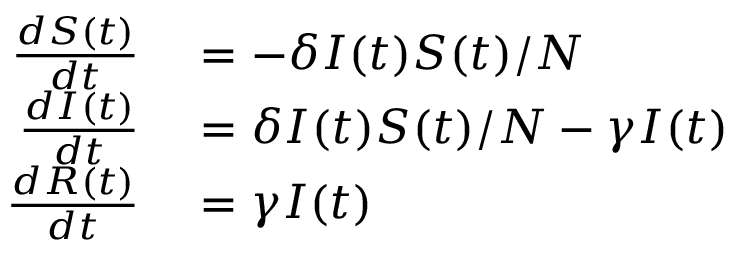Convert formula to latex. <formula><loc_0><loc_0><loc_500><loc_500>\begin{array} { r l } { \frac { d S ( t ) } { d t } } & = - \delta I ( t ) S ( t ) / N } \\ { \frac { d I ( t ) } { d t } } & = \delta I ( t ) S ( t ) / N - \gamma I ( t ) } \\ { \frac { d R ( t ) } { d t } } & = \gamma I ( t ) } \end{array}</formula> 